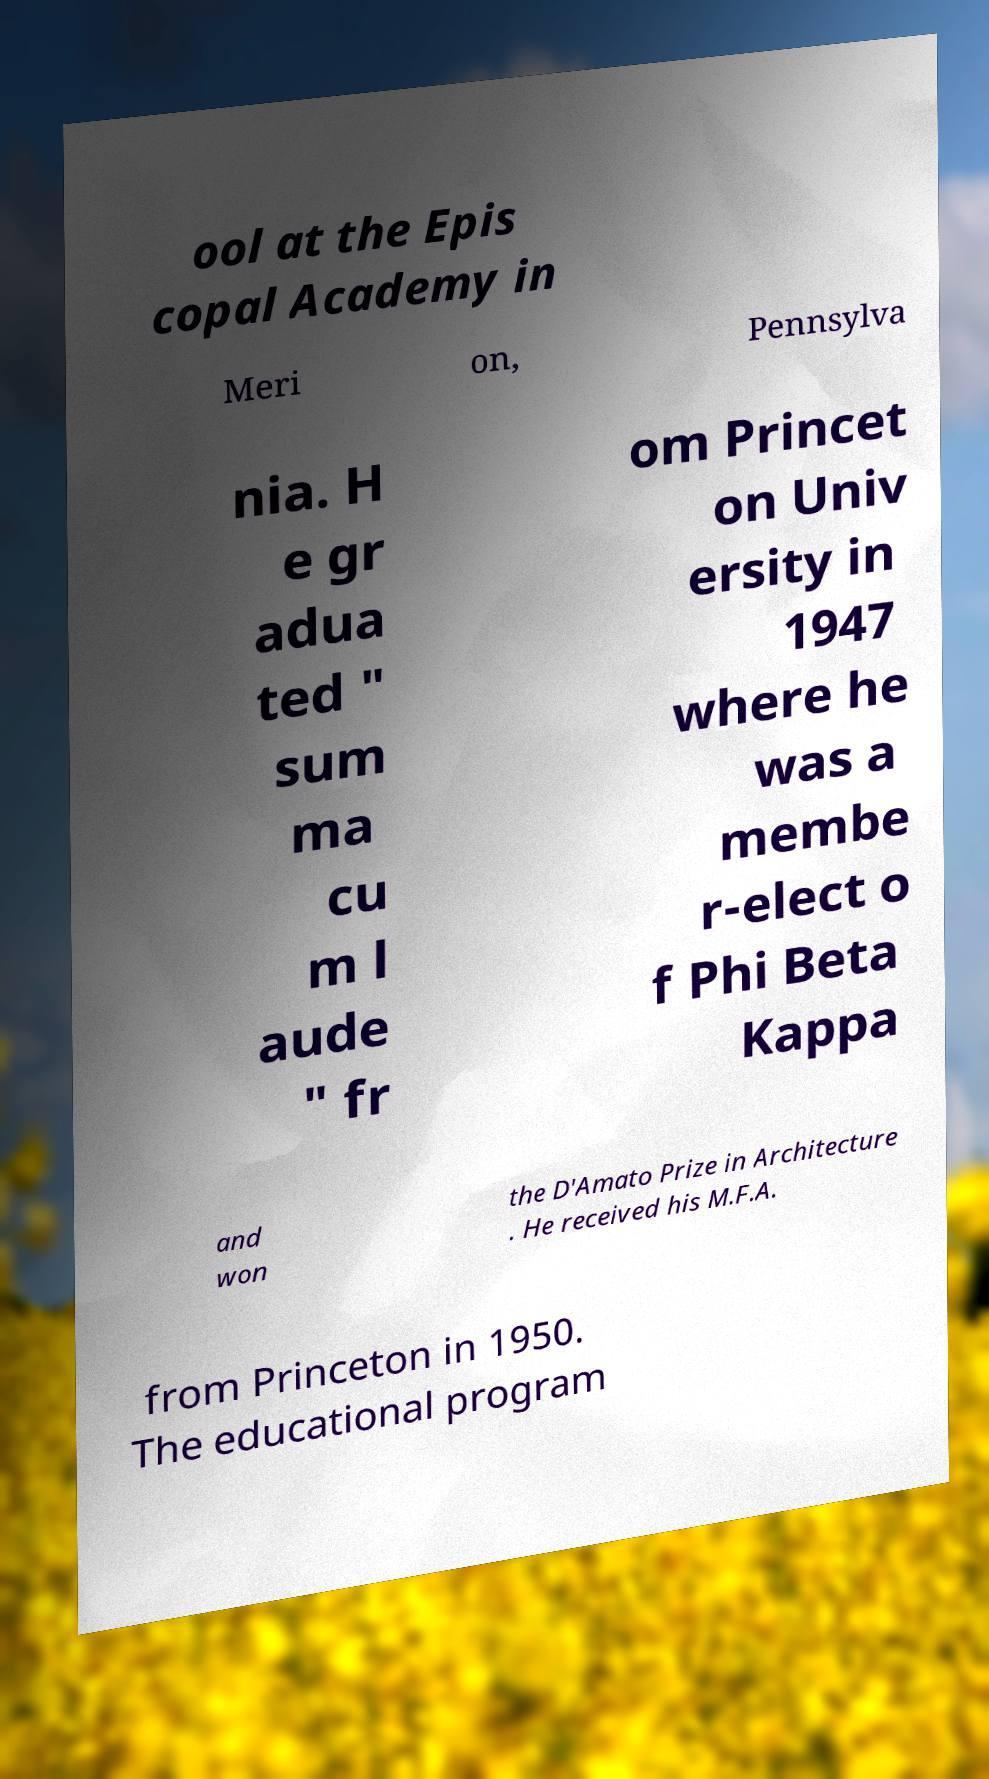Could you extract and type out the text from this image? ool at the Epis copal Academy in Meri on, Pennsylva nia. H e gr adua ted " sum ma cu m l aude " fr om Princet on Univ ersity in 1947 where he was a membe r-elect o f Phi Beta Kappa and won the D'Amato Prize in Architecture . He received his M.F.A. from Princeton in 1950. The educational program 